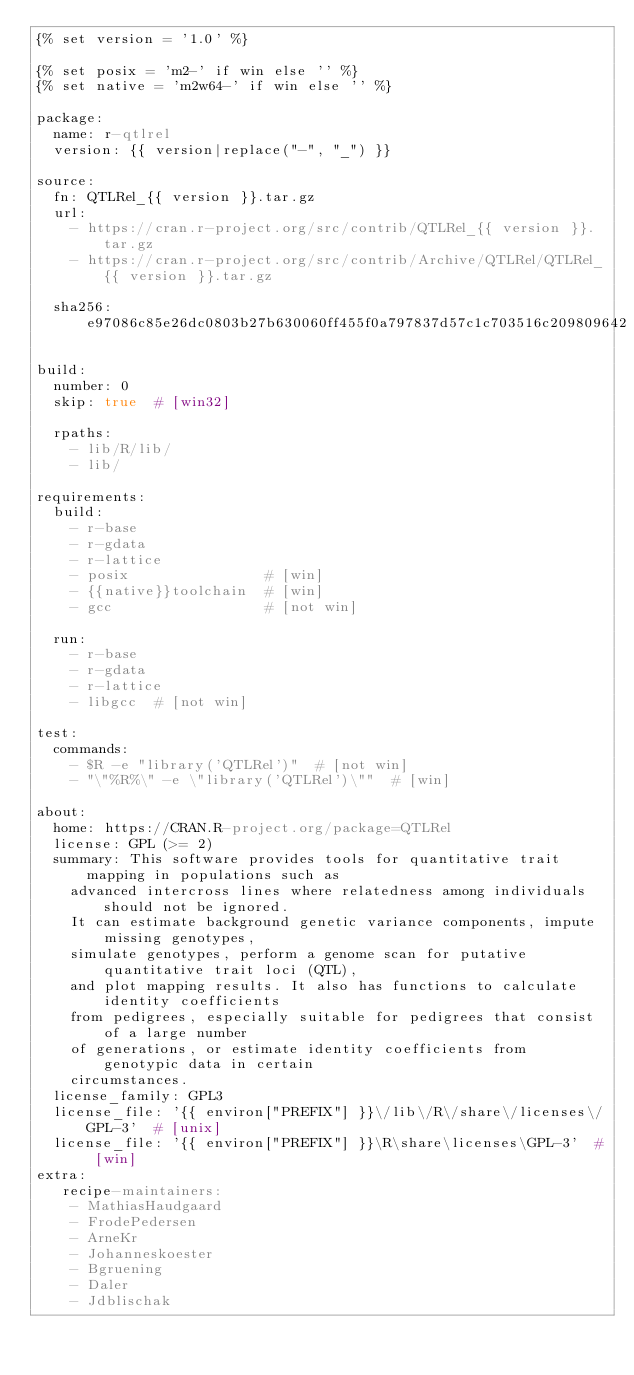<code> <loc_0><loc_0><loc_500><loc_500><_YAML_>{% set version = '1.0' %}

{% set posix = 'm2-' if win else '' %}
{% set native = 'm2w64-' if win else '' %}

package:
  name: r-qtlrel
  version: {{ version|replace("-", "_") }}

source:
  fn: QTLRel_{{ version }}.tar.gz
  url:
    - https://cran.r-project.org/src/contrib/QTLRel_{{ version }}.tar.gz
    - https://cran.r-project.org/src/contrib/Archive/QTLRel/QTLRel_{{ version }}.tar.gz

  sha256: e97086c85e26dc0803b27b630060ff455f0a797837d57c1c703516c209809642

build:
  number: 0
  skip: true  # [win32]

  rpaths:
    - lib/R/lib/
    - lib/

requirements:
  build:
    - r-base
    - r-gdata
    - r-lattice
    - posix                # [win]
    - {{native}}toolchain  # [win]
    - gcc                  # [not win]

  run:
    - r-base
    - r-gdata
    - r-lattice
    - libgcc  # [not win]

test:
  commands:
    - $R -e "library('QTLRel')"  # [not win]
    - "\"%R%\" -e \"library('QTLRel')\""  # [win]

about:
  home: https://CRAN.R-project.org/package=QTLRel
  license: GPL (>= 2)
  summary: This software provides tools for quantitative trait mapping in populations such as
    advanced intercross lines where relatedness among individuals should not be ignored.
    It can estimate background genetic variance components, impute missing genotypes,
    simulate genotypes, perform a genome scan for putative quantitative trait loci (QTL),
    and plot mapping results. It also has functions to calculate identity coefficients
    from pedigrees, especially suitable for pedigrees that consist of a large number
    of generations, or estimate identity coefficients from genotypic data in certain
    circumstances.
  license_family: GPL3
  license_file: '{{ environ["PREFIX"] }}\/lib\/R\/share\/licenses\/GPL-3'  # [unix]
  license_file: '{{ environ["PREFIX"] }}\R\share\licenses\GPL-3'  # [win]
extra:
   recipe-maintainers:
    - MathiasHaudgaard
    - FrodePedersen
    - ArneKr
    - Johanneskoester
    - Bgruening
    - Daler
    - Jdblischak
</code> 